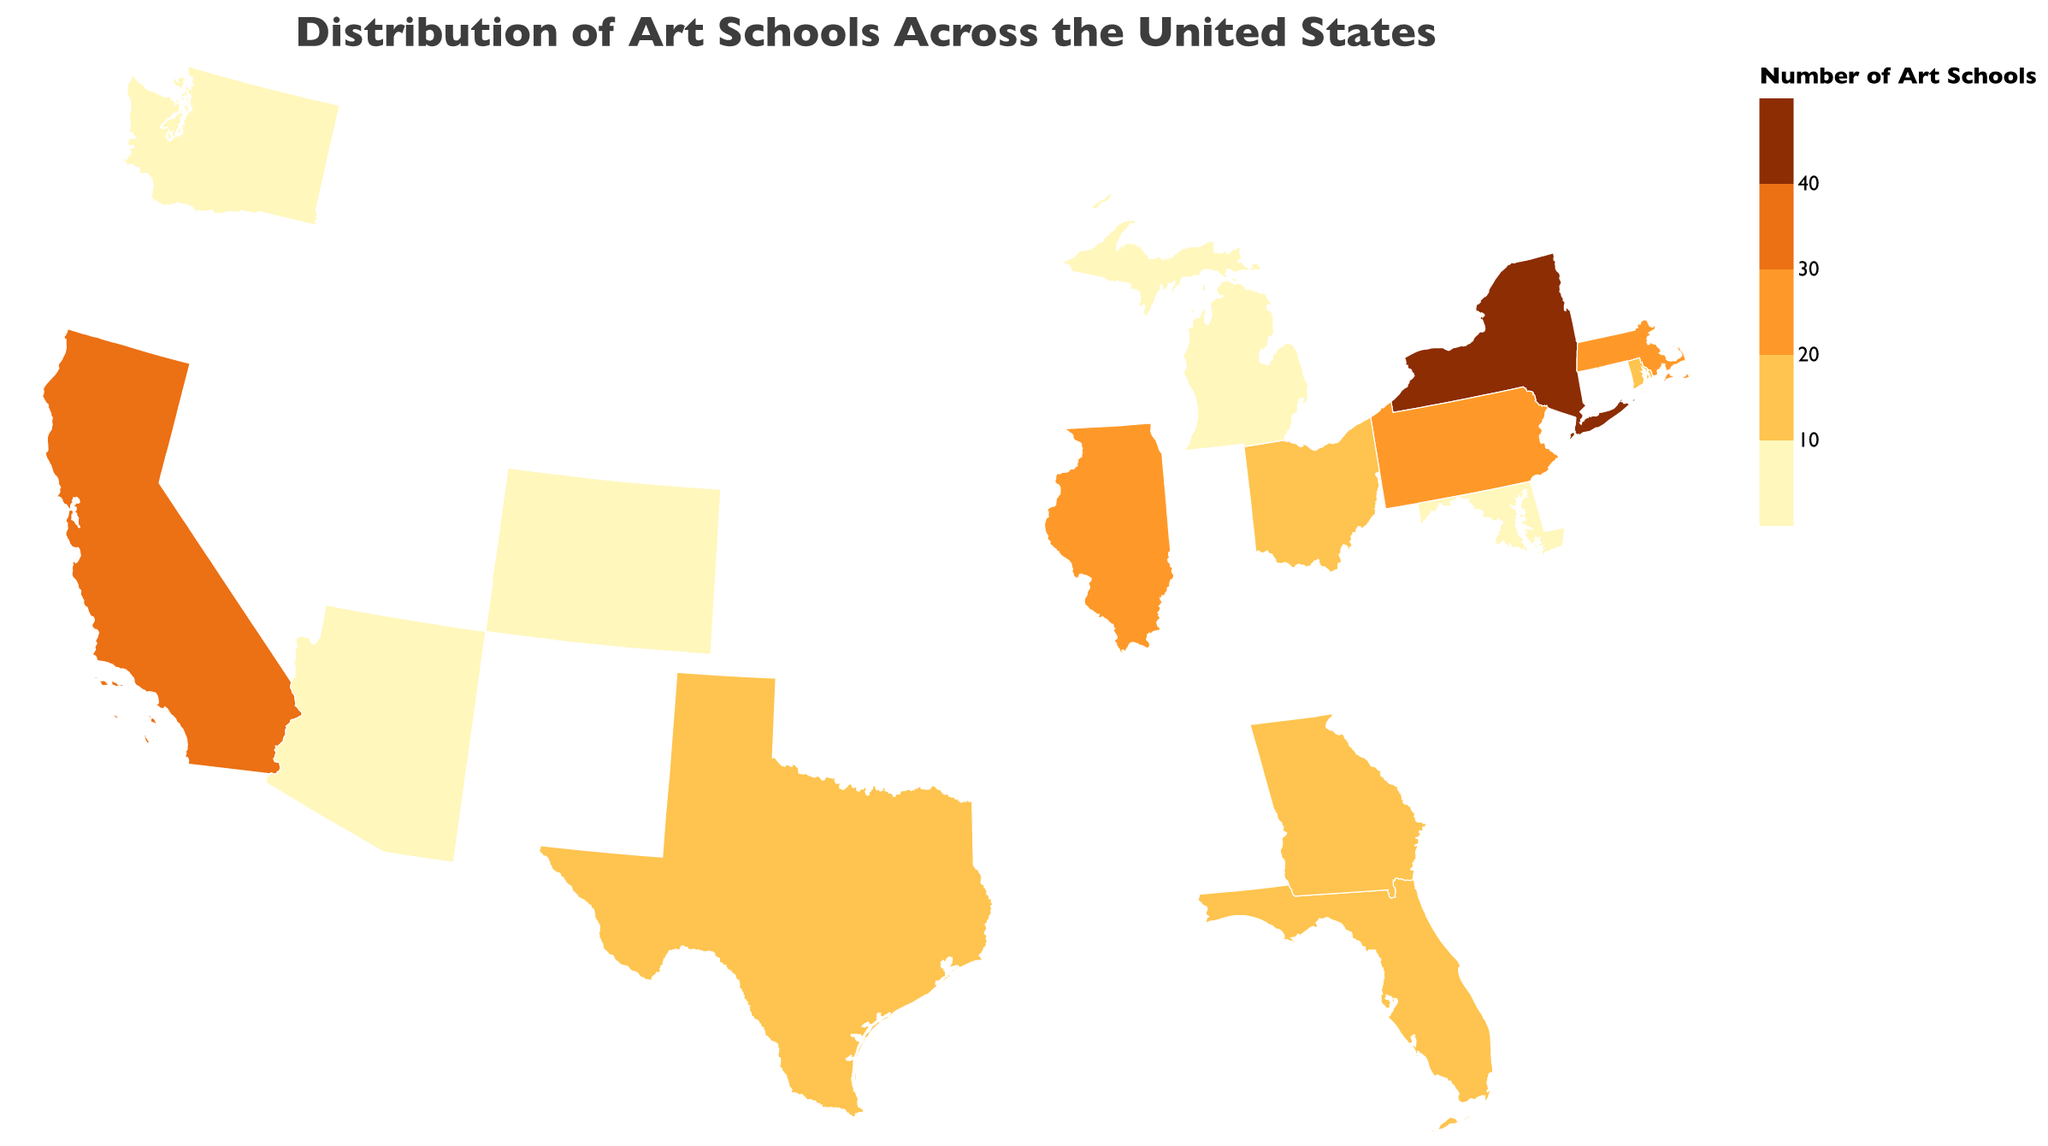What states have the highest concentration of art schools? By looking at the map, we can see that New York, California, Illinois, and Massachusetts have the highest concentrations, as indicated by the darker color shades. New York has the highest with 42 art schools.
Answer: New York, California, Illinois, Massachusetts How many art schools are there in the Midwest region? Summing up the number of art schools in the Midwest states listed, which are Illinois (25), Ohio (14), and Michigan (9), we get 25 + 14 + 9 = 48
Answer: 48 Which region has the greatest number of art schools in total? By calculating the sum of art schools in each region: Northeast (New York 42, Massachusetts 22, Pennsylvania 20, Rhode Island 12, Maryland 6), West (California 38, Washington 8, Colorado 7), Midwest (Illinois 25, Ohio 14, Michigan 9), Southeast (Florida 18, Georgia 10), Southwest (Texas 16, Arizona 5), the Northeast region has the greatest number of art schools in total with 42 + 22 + 20 + 12 + 6 = 102
Answer: Northeast Which state in the Southeast region has more art schools? There are only two Southeast states listed: Florida with 18 and Georgia with 10. Comparing these counts, Florida has more art schools.
Answer: Florida What is the most notable art program in California? The tooltip for California indicates "California Institute of the Arts" as the notable program.
Answer: California Institute of the Arts Is the Rhode Island School of Design located in a state with more than 10 art schools? For Rhode Island, the tooltip shows 12 art schools which is more than 10. So, yes, the Rhode Island School of Design is located in a state with more than 10 art schools.
Answer: Yes How many states in the data have less than 10 art schools? From the data, the states with less than 10 art schools are Michigan (9), Washington (8), Colorado (7), Maryland (6), and Arizona (5), making a total of 5 states.
Answer: 5 Which states have art schools count between 10 and 20 inclusively? The states with art school counts between 10 and 20 inclusive are Rhode Island (12), Georgia (10), and Florida (18), Pennsylvania (20), and Texas (16).
Answer: Rhode Island, Georgia, Florida, Pennsylvania, Texas Which state’s notable program is the Tyler School of Art and Architecture? Checking the tooltip for Tyler School of Art and Architecture, this program is notable in Pennsylvania.
Answer: Pennsylvania What color represents states with the highest number of art schools, and give an example of such a state? The states with the highest number of art schools are shaded in the darkest color. For example, New York is represented in this darkest color shade with 42 art schools.
Answer: Darkest shade, New York 